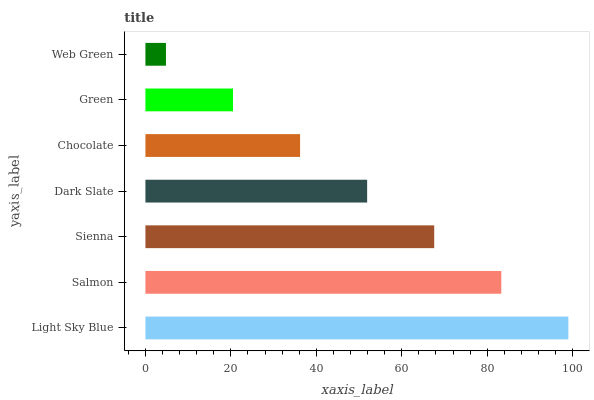Is Web Green the minimum?
Answer yes or no. Yes. Is Light Sky Blue the maximum?
Answer yes or no. Yes. Is Salmon the minimum?
Answer yes or no. No. Is Salmon the maximum?
Answer yes or no. No. Is Light Sky Blue greater than Salmon?
Answer yes or no. Yes. Is Salmon less than Light Sky Blue?
Answer yes or no. Yes. Is Salmon greater than Light Sky Blue?
Answer yes or no. No. Is Light Sky Blue less than Salmon?
Answer yes or no. No. Is Dark Slate the high median?
Answer yes or no. Yes. Is Dark Slate the low median?
Answer yes or no. Yes. Is Chocolate the high median?
Answer yes or no. No. Is Sienna the low median?
Answer yes or no. No. 